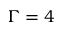<formula> <loc_0><loc_0><loc_500><loc_500>\Gamma = 4</formula> 